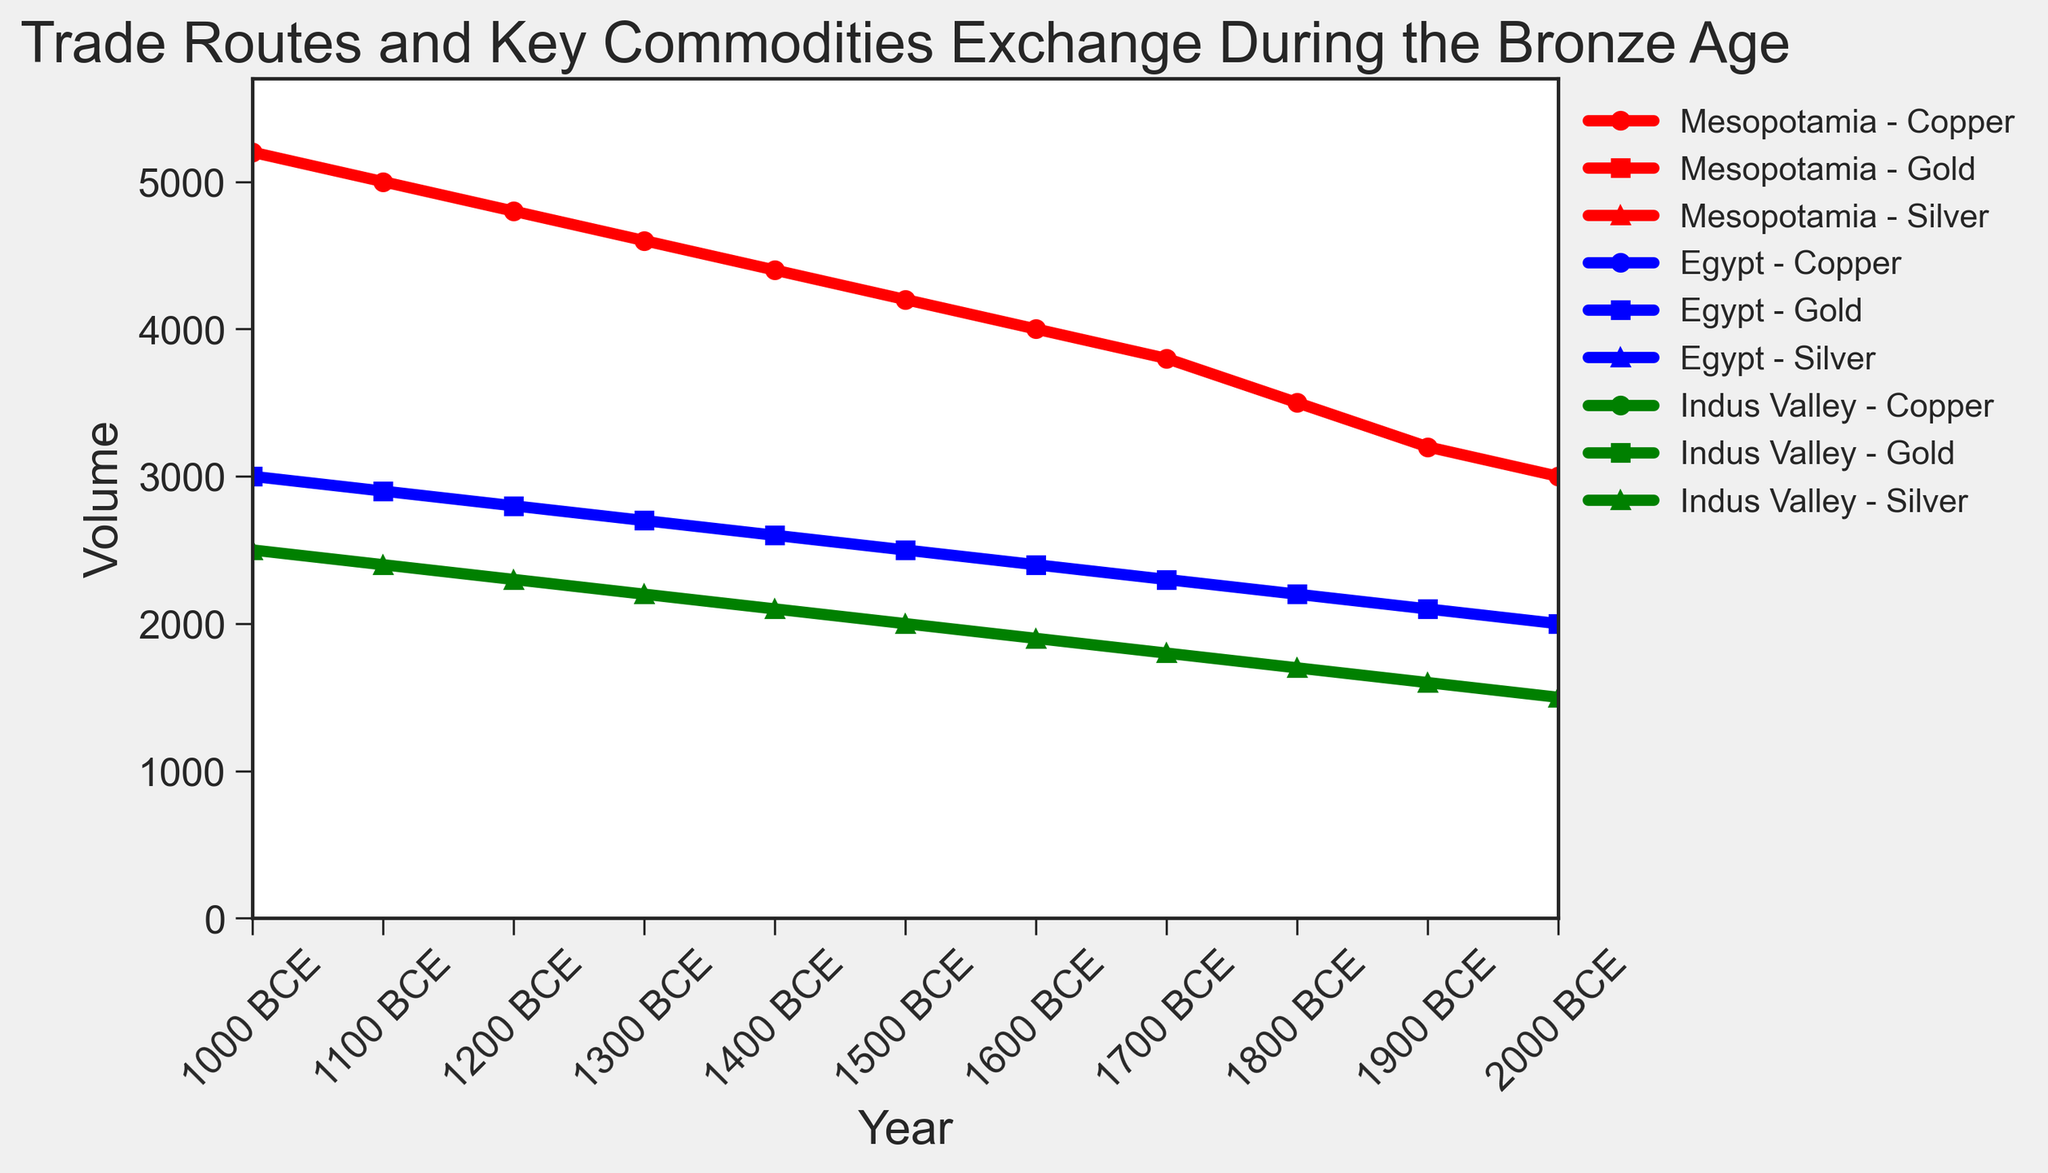Which commodity had the highest volume in 1000 BCE? By examining the line chart and comparing the volumes of Copper, Gold, and Silver in 1000 BCE, we see that Copper has the highest volume among the listed commodities.
Answer: Copper How did the volume of Copper trade in Mesopotamia change from 2000 BCE to 1000 BCE? Looking at the data points for Mesopotamia's Copper trade between 2000 BCE and 1000 BCE, we can see a consistent increase in volume from 3000 to 5200.
Answer: Increased What is the difference in the volume of Gold traded by Egypt between 2000 BCE and 1000 BCE? In 2000 BCE, Egypt traded 2000 units of Gold and in 1000 BCE, they traded 3000 units. The difference is calculated by subtracting 2000 from 3000.
Answer: 1000 units Which trio of regions and commodities has the highest traded volume in 1800 BCE? Comparing the volumes of all commodities in 1800 BCE: Copper in Mesopotamia (3500), Gold in Egypt (2200), and Silver in Indus Valley (1700). The highest traded volume is Copper in Mesopotamia.
Answer: Mesopotamia - Copper What is the average volume of Silver traded across all years in the Indus Valley? The volumes of Silver traded in the Indus Valley from 2000 BCE to 1000 BCE are: 1500, 1600, 1700, 1800, 1900, 2000, 2100, 2200, 2300, 2400, 2500. Adding these values gives 22000, and the average is 22000 / 11.
Answer: 2000 How did the volume of Gold trade in Egypt evolve from 2000 BCE to 1500 BCE? Observing the data points for Gold in Egypt, the volume consistently increases in increments: 2000 to 2500 from 2000 BCE to 1500 BCE.
Answer: Increased Compare the growth rates of Copper and Gold trades from 2000 BCE to 1000 BCE. Which one had a higher growth rate? Copper starts at 3000 and ends at 5200 (growth of 2200), while Gold starts at 2000 and ends at 3000 (growth of 1000). The growth rate can be compared by the increments: Copper’s growth by 2200 is higher than Gold’s growth by 1000.
Answer: Copper Which region saw the least change in the volume of their key commodity trade from 2000 BCE to 1000 BCE? We compare the changes: Mesopotamia (Copper) increased by 2200 (5200-3000), Egypt (Gold) by 1000 (3000-2000), and Indus Valley (Silver) by 1000 (2500-1500). Indus Valley and Egypt saw the smallest change, both 1000 units.
Answer: Indus Valley and Egypt What was the total volume of trade for all commodities in Egypt in 1700 BCE? To find the total volume in Egypt in 1700 BCE, add the volumes of Gold traded: 2300.
Answer: 2300 